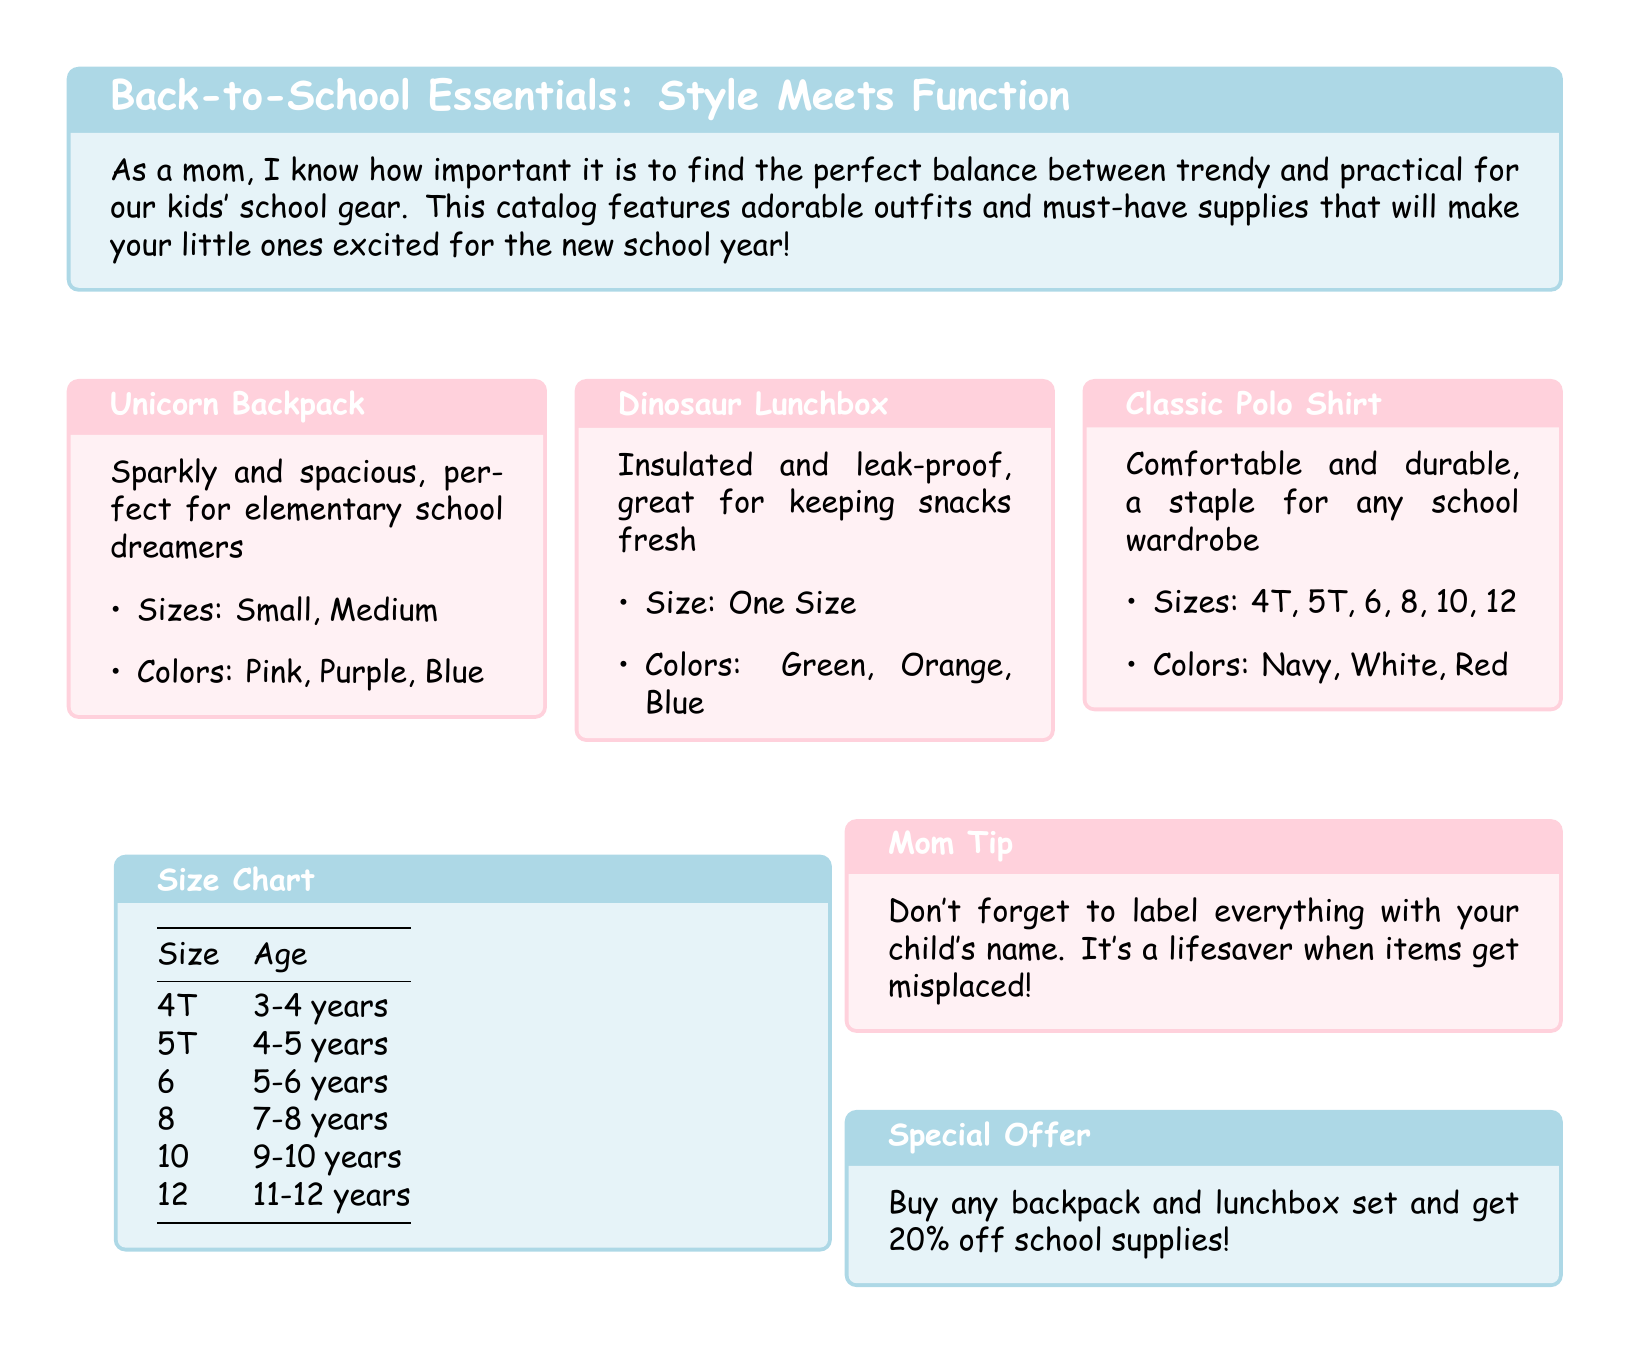What is the title of the catalog? The title of the catalog is the main heading at the top, which describes the content about school items.
Answer: Back-to-School Essentials: Style Meets Function What is one color option for the Unicorn Backpack? The answer is found in the item description for the Unicorn Backpack, which lists the available colors.
Answer: Pink What sizes are available for the Classic Polo Shirt? The sizes listed in the description for the Classic Polo Shirt indicate the options available for customers.
Answer: 4T, 5T, 6, 8, 10, 12 What age group corresponds to size 10? The size chart indicates which age group each size corresponds to, including size 10.
Answer: 9-10 years What is the special offer mentioned in the catalog? The information about the special offer can be directly found in the respective box discussing promotions.
Answer: 20% off school supplies What is a key tip included for parents? The tips provided in the catalog offer valuable advice to parents regarding school supplies.
Answer: Label everything with your child's name What is the color of the Dinosaur Lunchbox? The items listed include different color options, and the Dinosaur Lunchbox provides this specific detail.
Answer: Green, Orange, Blue What is included in the size chart? The size chart includes sizes and their corresponding age groups for easy reference for parents.
Answer: Size and Age 